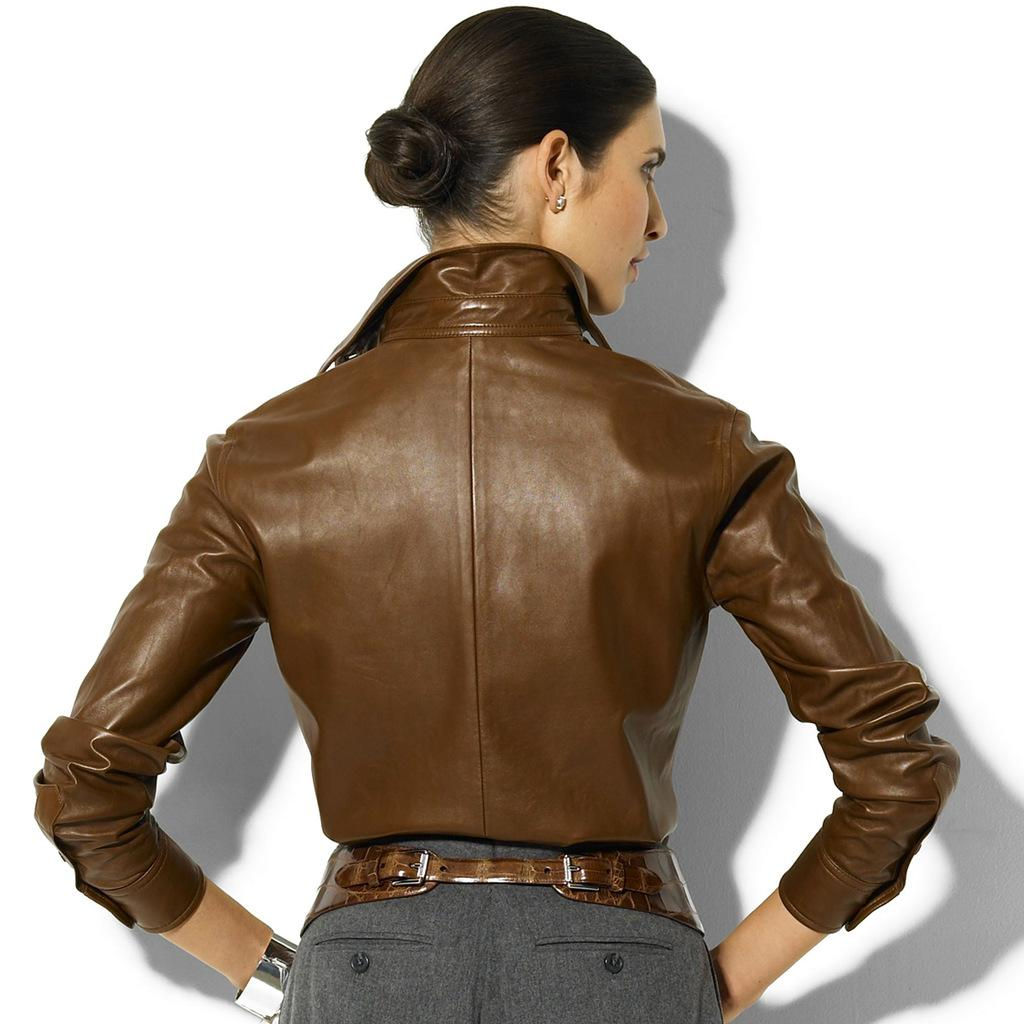Who is present in the image? There is a woman in the image. What is the woman doing in the image? The woman is standing. What is the woman wearing in the image? The woman is wearing a brown jacket. What can be seen in the background of the image? There is a well in the background of the image. What type of fish can be seen swimming in the feast in the image? There is no feast or fish present in the image; it features a woman standing and a well in the background. 